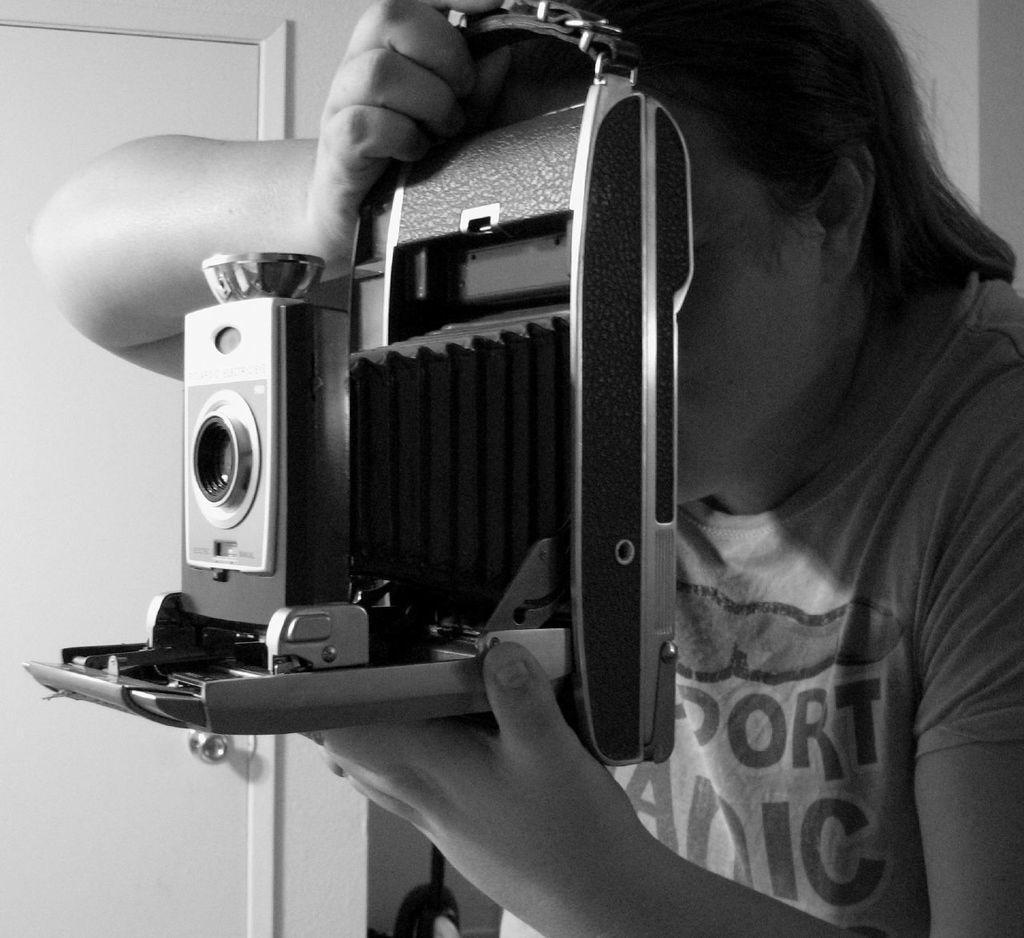How would you summarize this image in a sentence or two? In this image I can see a person is holding a camera in hand. In the background I can see a door and wall. This image is taken in a room. 